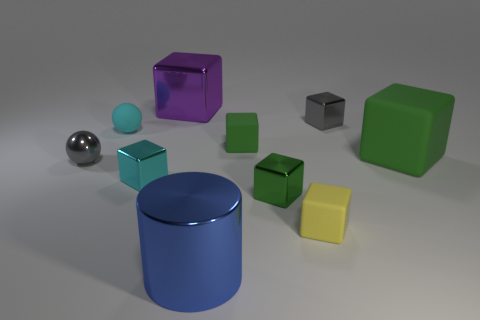Does the small green cube behind the large matte cube have the same material as the large block to the left of the tiny yellow object?
Make the answer very short. No. What number of other green objects have the same shape as the small green metallic thing?
Your answer should be very brief. 2. There is a small block that is the same color as the matte ball; what is its material?
Keep it short and to the point. Metal. What number of objects are either tiny red objects or tiny cyan objects that are behind the gray sphere?
Provide a short and direct response. 1. What is the material of the tiny gray ball?
Ensure brevity in your answer.  Metal. There is a big green object that is the same shape as the small yellow thing; what is its material?
Your answer should be very brief. Rubber. There is a tiny shiny cube that is behind the gray metallic object that is on the left side of the big purple block; what color is it?
Provide a succinct answer. Gray. How many metal things are either big green cubes or small red cubes?
Offer a very short reply. 0. Do the tiny gray cube and the large cylinder have the same material?
Give a very brief answer. Yes. The small green thing in front of the small cube that is on the left side of the blue metallic cylinder is made of what material?
Your response must be concise. Metal. 